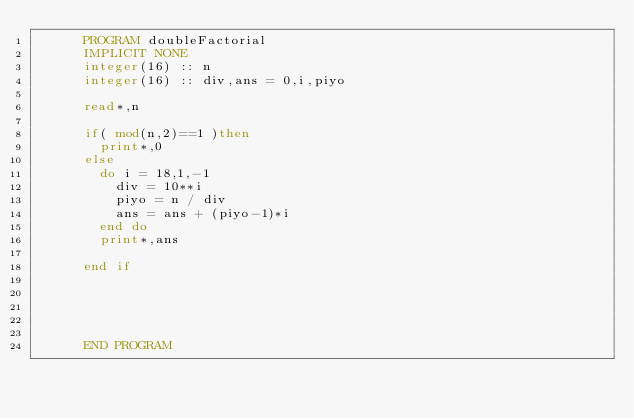Convert code to text. <code><loc_0><loc_0><loc_500><loc_500><_FORTRAN_>      PROGRAM doubleFactorial
      IMPLICIT NONE
      integer(16) :: n
      integer(16) :: div,ans = 0,i,piyo
      
      read*,n
      
      if( mod(n,2)==1 )then
        print*,0
      else
        do i = 18,1,-1
          div = 10**i
          piyo = n / div
          ans = ans + (piyo-1)*i
        end do
        print*,ans
        
      end if
      
      
      
      
      
      END PROGRAM</code> 